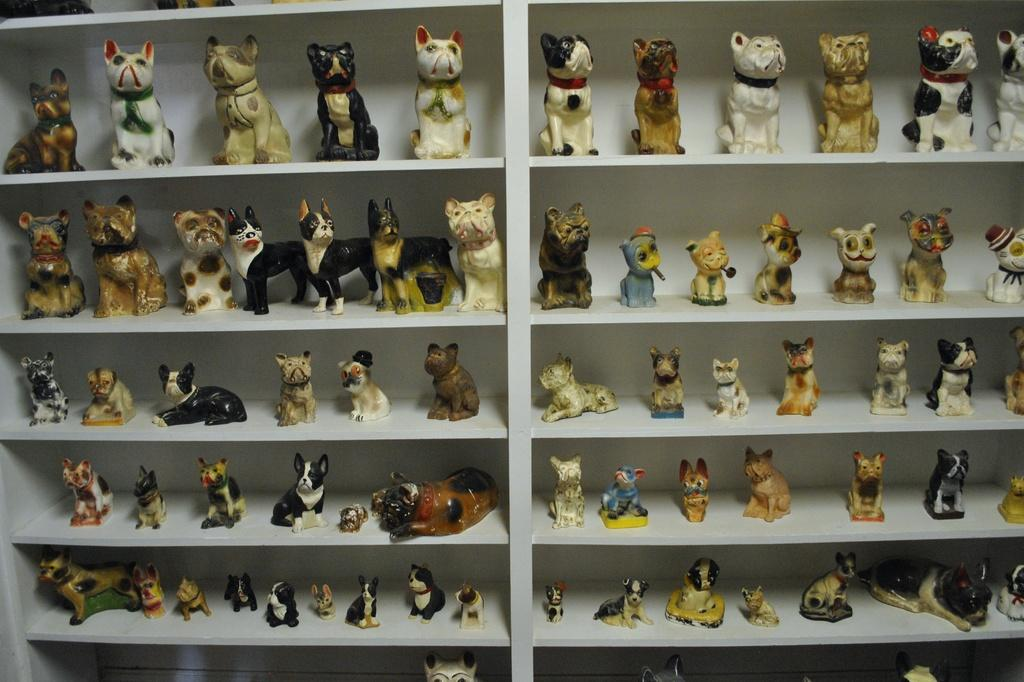What type of toys are present in the image? There are toys of dogs and cats in the image. How are the toys arranged in the image? The toys are kept in a rack. What note is being played by the deer in the image? There is no deer present in the image, and therefore no note can be played by a deer. 